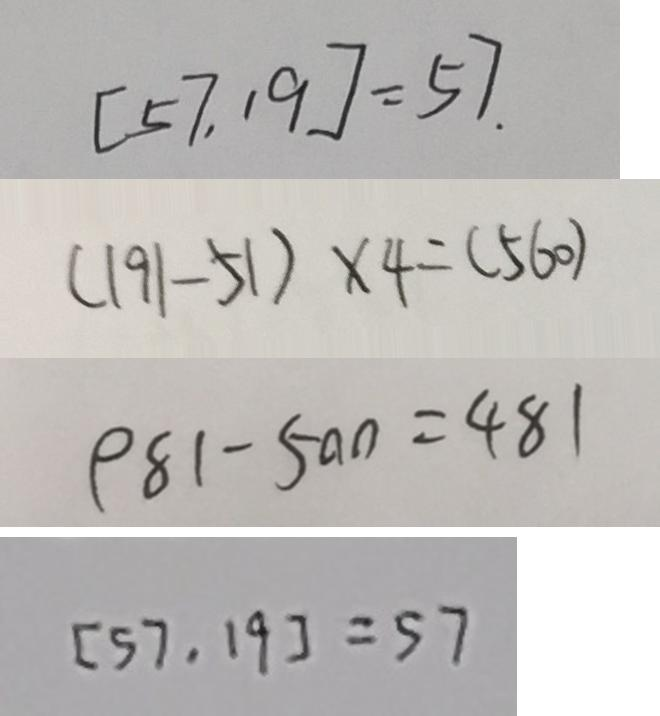Convert formula to latex. <formula><loc_0><loc_0><loc_500><loc_500>[ 5 7 , 1 9 ] = 5 7 . 
 ( 1 9 1 - 5 1 ) \times 4 = ( 5 6 0 ) 
 9 8 1 - 5 0 0 = 4 8 1 
 [ 5 7 , 1 9 ] = 5 7</formula> 